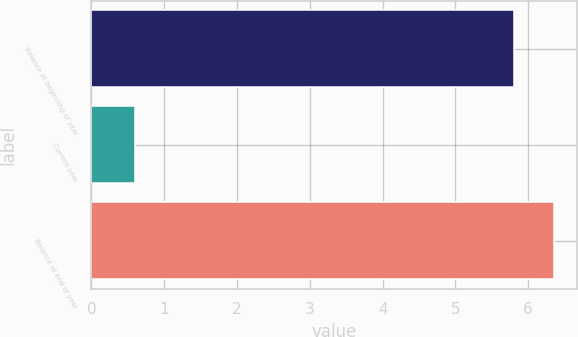Convert chart. <chart><loc_0><loc_0><loc_500><loc_500><bar_chart><fcel>Balance at beginning of year<fcel>Current year<fcel>Balance at end of year<nl><fcel>5.8<fcel>0.6<fcel>6.36<nl></chart> 